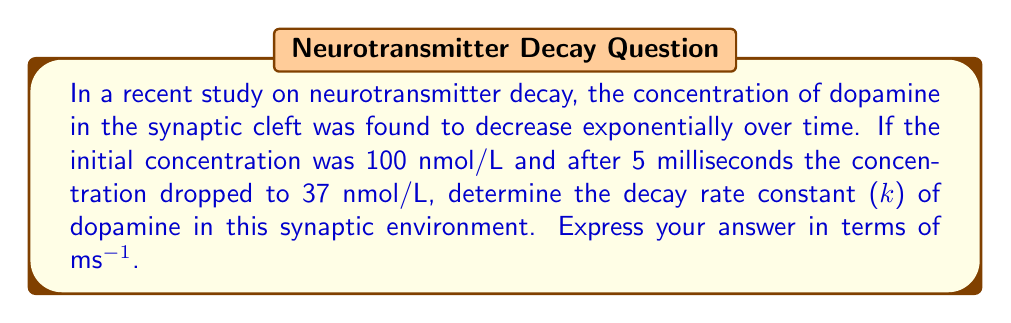Help me with this question. Let's approach this step-by-step using the exponential decay function:

1) The general form of exponential decay is:
   $$ C(t) = C_0 e^{-kt} $$
   where $C(t)$ is the concentration at time $t$, $C_0$ is the initial concentration, $k$ is the decay rate constant, and $t$ is time.

2) We know:
   $C_0 = 100$ nmol/L
   $C(5) = 37$ nmol/L
   $t = 5$ ms

3) Substituting these values into the equation:
   $$ 37 = 100 e^{-k(5)} $$

4) Divide both sides by 100:
   $$ 0.37 = e^{-5k} $$

5) Take the natural logarithm of both sides:
   $$ \ln(0.37) = -5k $$

6) Solve for $k$:
   $$ k = -\frac{\ln(0.37)}{5} $$

7) Calculate:
   $$ k = -\frac{-0.9943}{5} = 0.19886 \text{ ms}^{-1} $$

8) Round to 3 decimal places:
   $$ k \approx 0.199 \text{ ms}^{-1} $$
Answer: $0.199 \text{ ms}^{-1}$ 